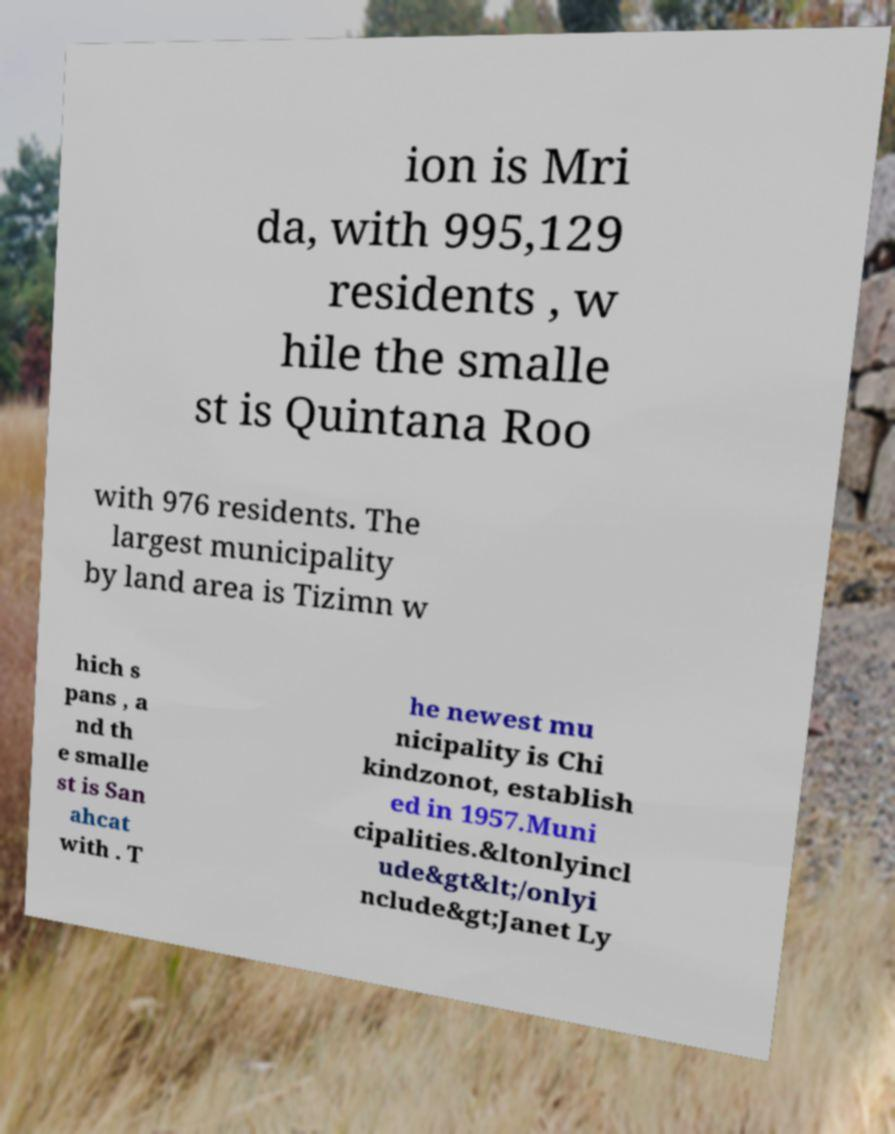What messages or text are displayed in this image? I need them in a readable, typed format. ion is Mri da, with 995,129 residents , w hile the smalle st is Quintana Roo with 976 residents. The largest municipality by land area is Tizimn w hich s pans , a nd th e smalle st is San ahcat with . T he newest mu nicipality is Chi kindzonot, establish ed in 1957.Muni cipalities.&ltonlyincl ude&gt&lt;/onlyi nclude&gt;Janet Ly 